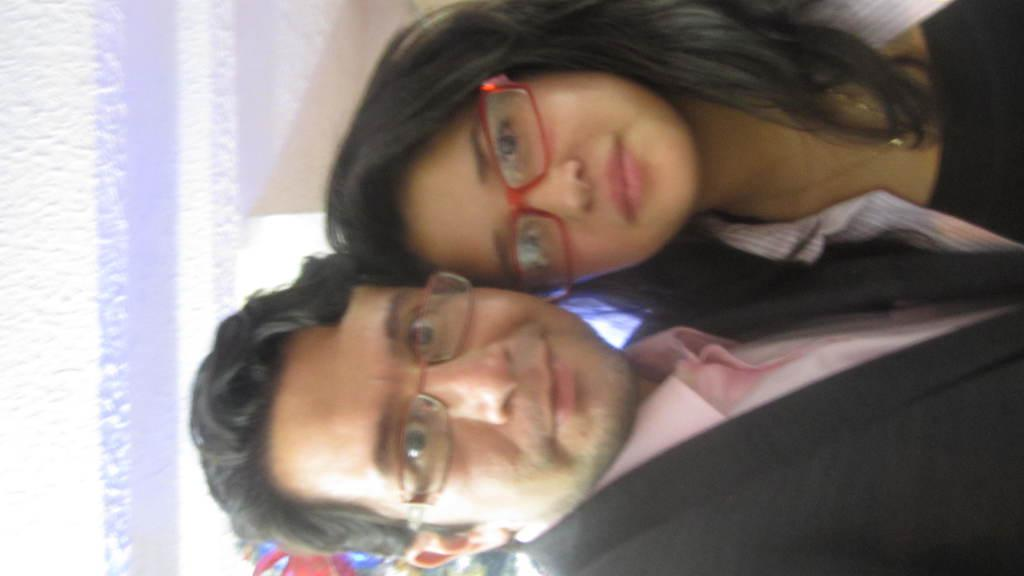What is the gender of the person in the image wearing glasses? There is a man in the image wearing glasses. What is the gender of the other person in the image wearing glasses? There is a woman in the image wearing glasses. What can be seen in the background of the image? There is a wall in the background of the image. How many dogs are present in the image? There are no dogs present in the image. What type of carpenter is the man in the image? The man in the image is not a carpenter; he is simply a man wearing glasses. 